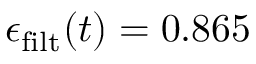Convert formula to latex. <formula><loc_0><loc_0><loc_500><loc_500>\epsilon _ { f i l t } ( t ) = 0 . 8 6 5</formula> 